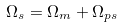<formula> <loc_0><loc_0><loc_500><loc_500>\Omega _ { s } = \Omega _ { m } + \Omega _ { p s }</formula> 